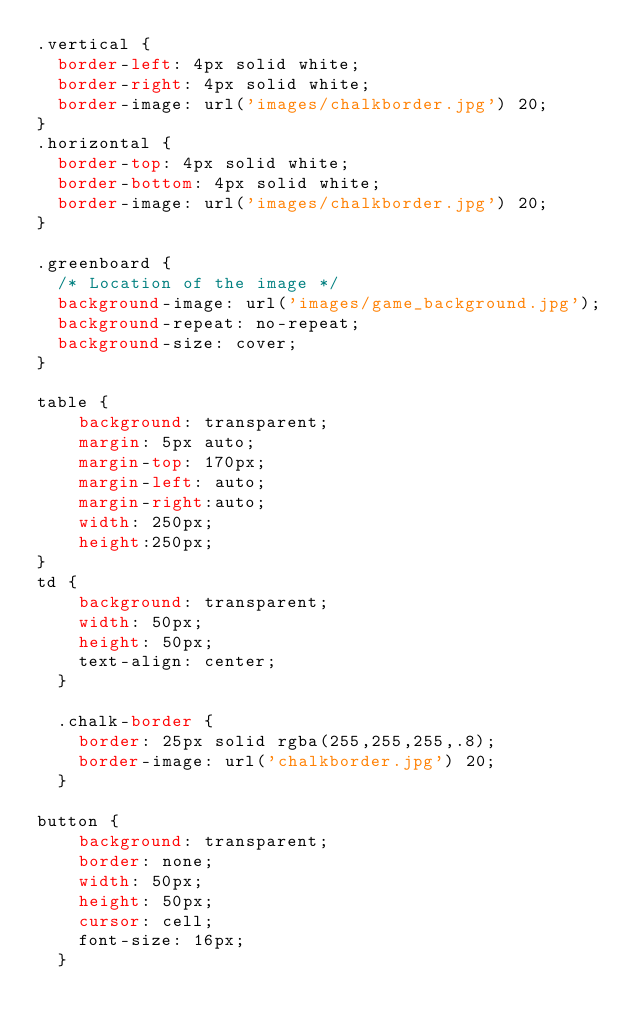Convert code to text. <code><loc_0><loc_0><loc_500><loc_500><_CSS_>.vertical {
  border-left: 4px solid white;
  border-right: 4px solid white;
  border-image: url('images/chalkborder.jpg') 20;
}
.horizontal {
  border-top: 4px solid white;
  border-bottom: 4px solid white;
  border-image: url('images/chalkborder.jpg') 20;
}

.greenboard {
  /* Location of the image */
  background-image: url('images/game_background.jpg');
  background-repeat: no-repeat;
  background-size: cover;
}

table {
    background: transparent;
    margin: 5px auto;
    margin-top: 170px;
    margin-left: auto;
    margin-right:auto;
    width: 250px;
    height:250px;
}
td {
    background: transparent;
    width: 50px;
    height: 50px;
    text-align: center;
  }

  .chalk-border {
    border: 25px solid rgba(255,255,255,.8);
    border-image: url('chalkborder.jpg') 20;
  }

button {
    background: transparent;
    border: none;
    width: 50px;
    height: 50px;
    cursor: cell;
    font-size: 16px;
  }</code> 